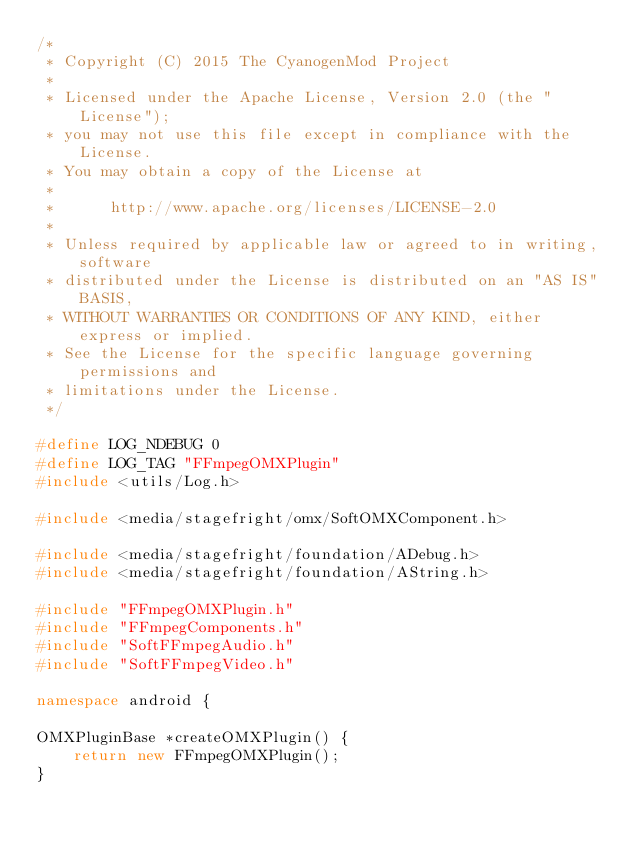<code> <loc_0><loc_0><loc_500><loc_500><_C++_>/*
 * Copyright (C) 2015 The CyanogenMod Project
 *
 * Licensed under the Apache License, Version 2.0 (the "License");
 * you may not use this file except in compliance with the License.
 * You may obtain a copy of the License at
 *
 *      http://www.apache.org/licenses/LICENSE-2.0
 *
 * Unless required by applicable law or agreed to in writing, software
 * distributed under the License is distributed on an "AS IS" BASIS,
 * WITHOUT WARRANTIES OR CONDITIONS OF ANY KIND, either express or implied.
 * See the License for the specific language governing permissions and
 * limitations under the License.
 */

#define LOG_NDEBUG 0
#define LOG_TAG "FFmpegOMXPlugin"
#include <utils/Log.h>

#include <media/stagefright/omx/SoftOMXComponent.h>

#include <media/stagefright/foundation/ADebug.h>
#include <media/stagefright/foundation/AString.h>

#include "FFmpegOMXPlugin.h"
#include "FFmpegComponents.h"
#include "SoftFFmpegAudio.h"
#include "SoftFFmpegVideo.h"

namespace android {

OMXPluginBase *createOMXPlugin() {
    return new FFmpegOMXPlugin();
}
</code> 